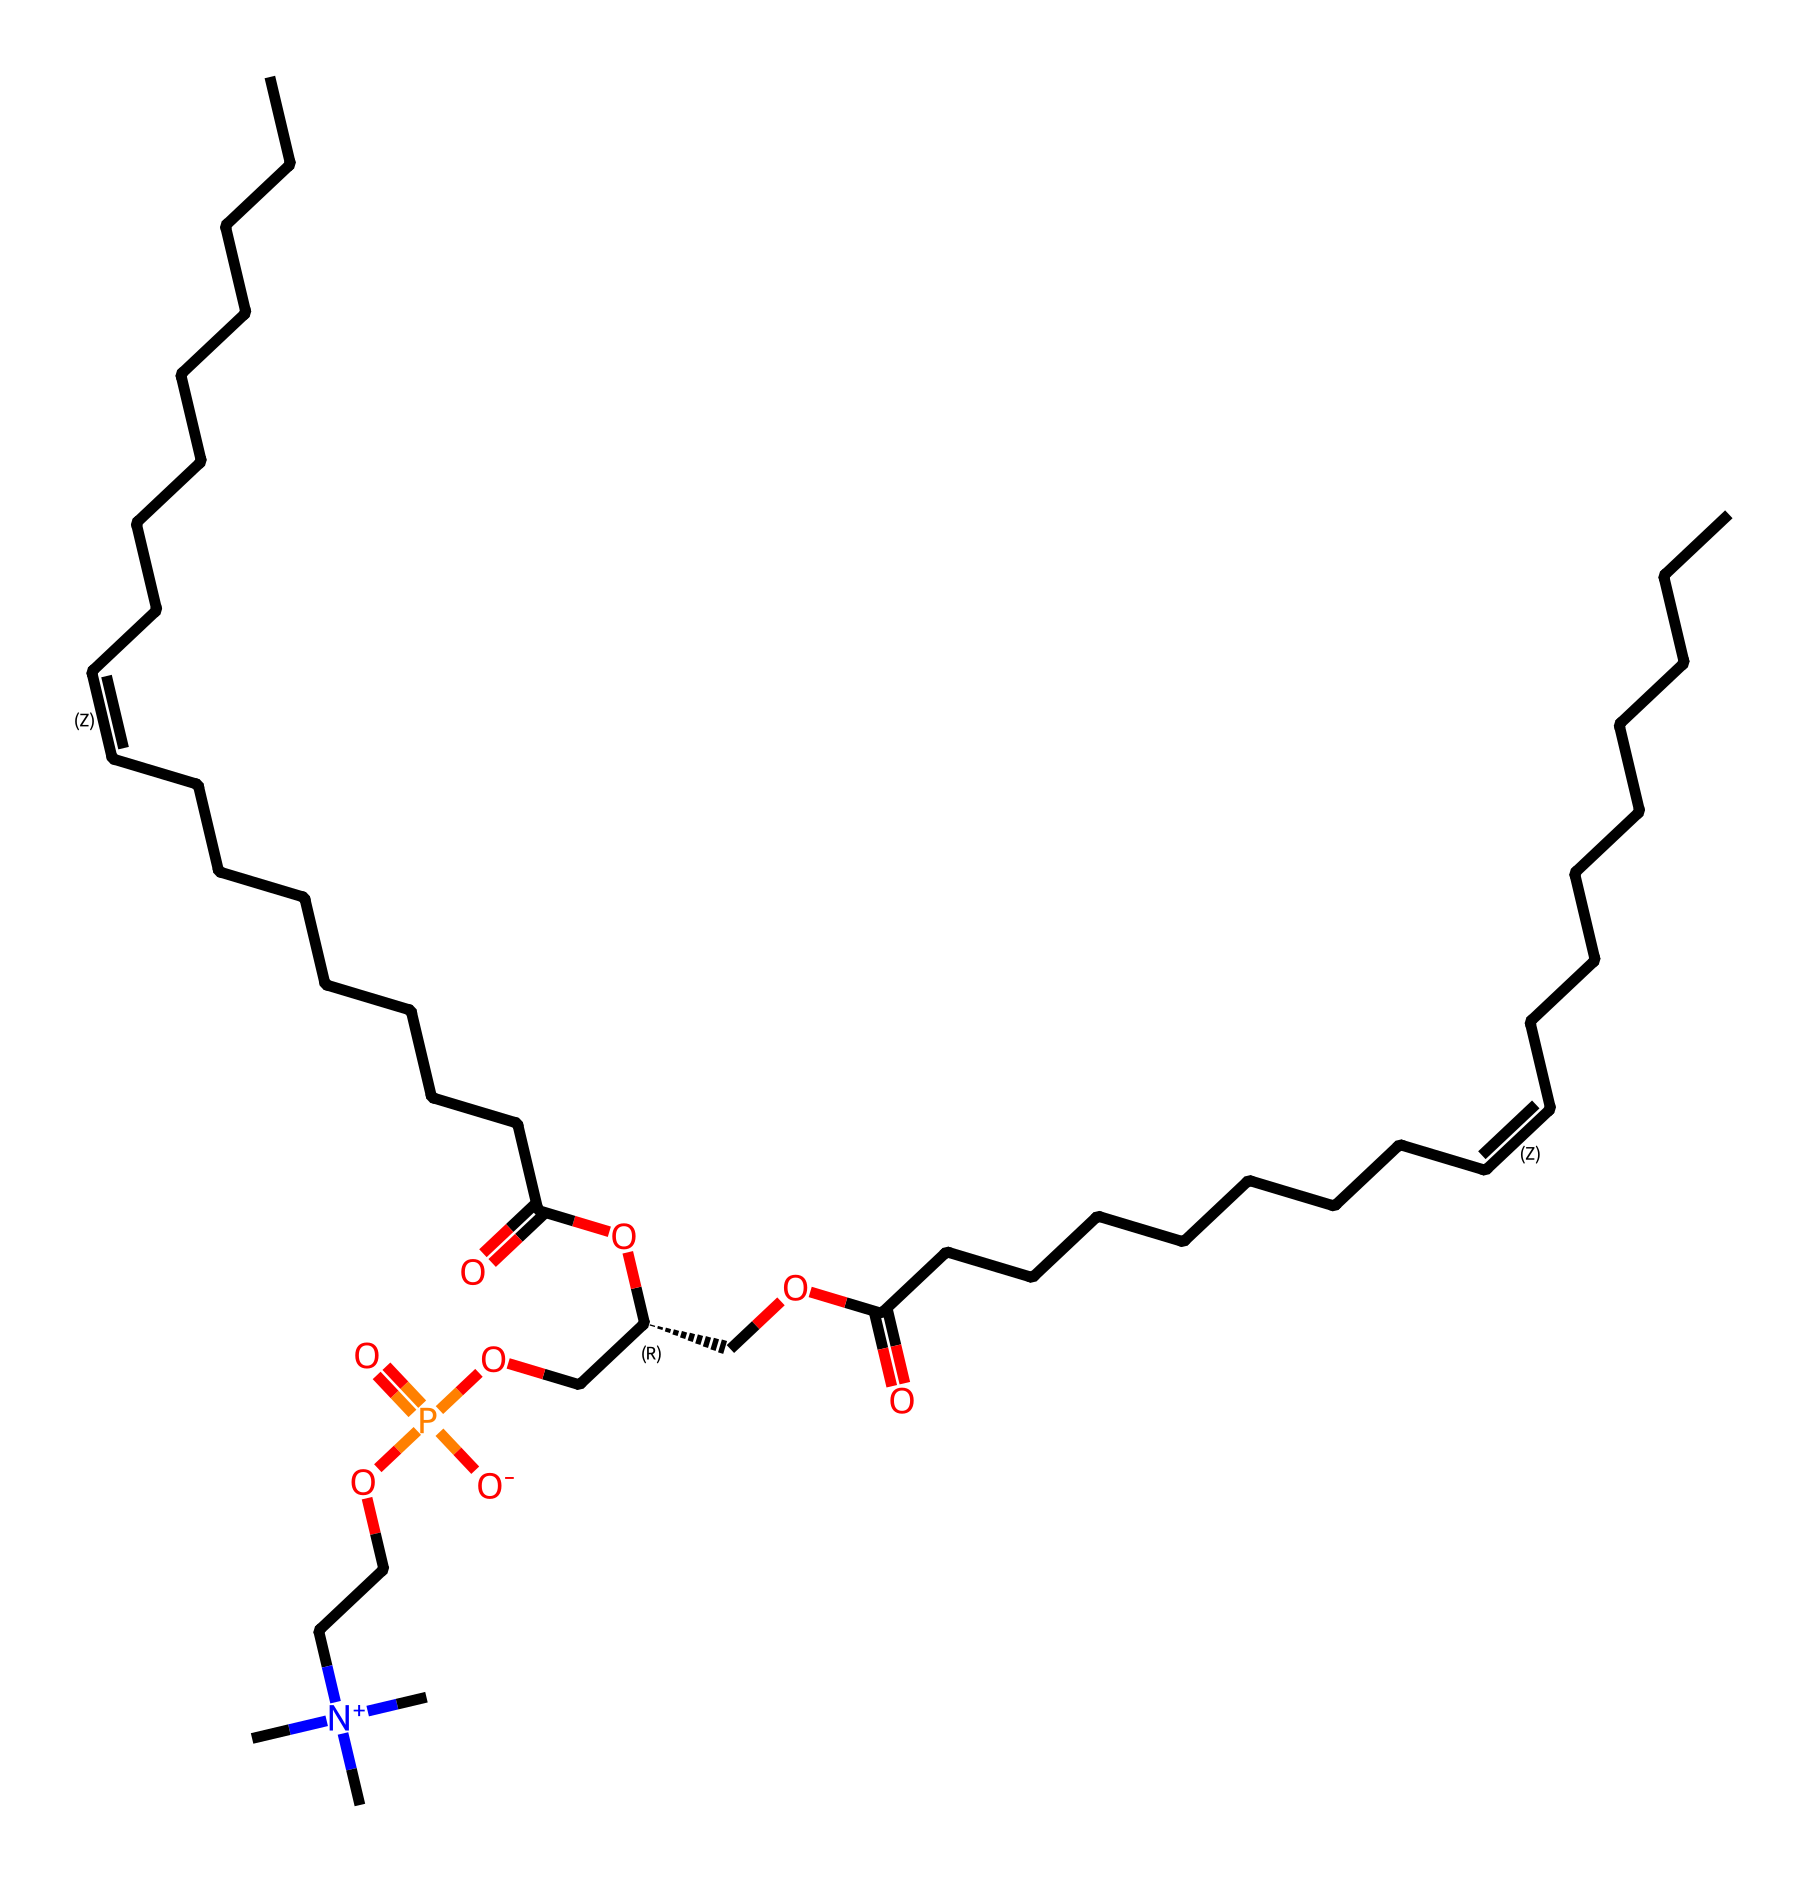What is the molecular weight of lecithin? To find the molecular weight, one would need to calculate the combined weight of all the atoms present in the structure, including carbon, hydrogen, oxygen, and phosphorus. By counting the types and quantities of each atom from the SMILES representation, the total molecular weight of lecithin can be derived.
Answer: molecular weight How many carbon atoms are in lecithin? By analyzing the structural formula, we count the carbon (C) atoms explicitly indicated in the SMILES notation. Carbon atoms can be identified by their representation within the SMILES string, leading to a total count.
Answer: twenty-four What type of lipid is lecithin classified as? Lecithin is classified as a phospholipid, which is characterized by the presence of both fatty acid tails and a phosphate group. This classification is supported by the SMILES structure showing fatty acid chains and a phosphate-containing group.
Answer: phospholipid What functional group in lecithin contributes to its emulsifying properties? The phosphate group in the head of the lecithin molecule is crucial for its ability to act as an emulsifier. This polar region interacts with water, while the nonpolar fatty acid tails interact with oils, making it effective in stabilizing emulsions.
Answer: phosphate group How many double bonds are present in the fatty acyl chains of lecithin? The SMILES representation indicates the presence of alternating "C=C" symbols, which denote double bonds in the hydrocarbon chains. Analyzing these segments, we can count the total number of double bonds present in the structure.
Answer: two 